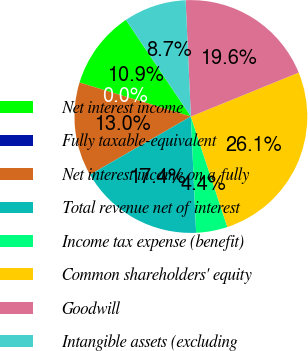Convert chart. <chart><loc_0><loc_0><loc_500><loc_500><pie_chart><fcel>Net interest income<fcel>Fully taxable-equivalent<fcel>Net interest income on a fully<fcel>Total revenue net of interest<fcel>Income tax expense (benefit)<fcel>Common shareholders' equity<fcel>Goodwill<fcel>Intangible assets (excluding<nl><fcel>10.87%<fcel>0.0%<fcel>13.04%<fcel>17.39%<fcel>4.35%<fcel>26.08%<fcel>19.56%<fcel>8.7%<nl></chart> 